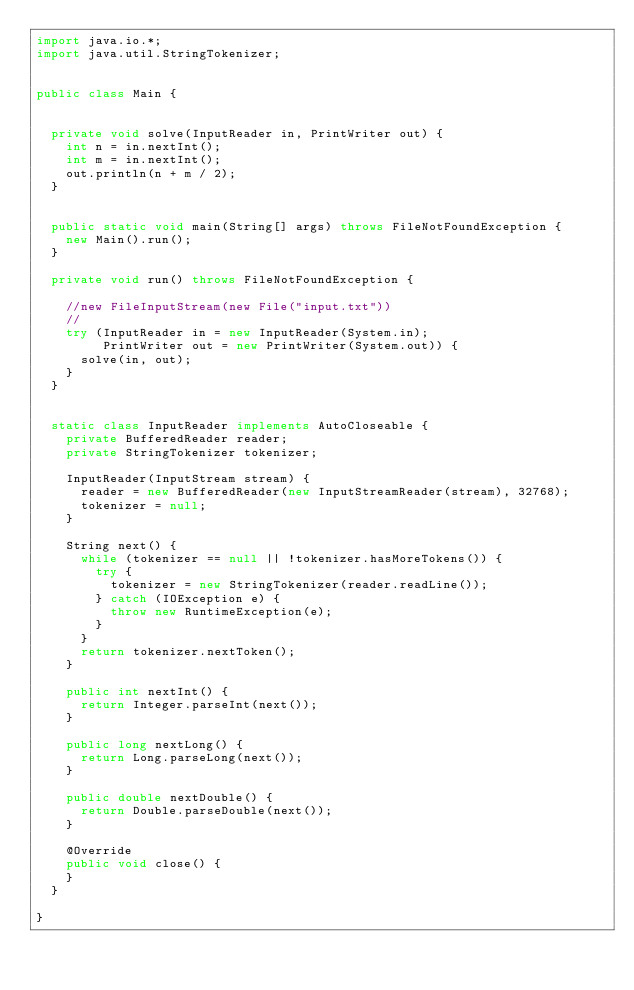<code> <loc_0><loc_0><loc_500><loc_500><_Java_>import java.io.*;
import java.util.StringTokenizer;


public class Main {


  private void solve(InputReader in, PrintWriter out) {
    int n = in.nextInt();
    int m = in.nextInt();
    out.println(n + m / 2);
  }


  public static void main(String[] args) throws FileNotFoundException {
    new Main().run();
  }

  private void run() throws FileNotFoundException {

    //new FileInputStream(new File("input.txt"))
    //
    try (InputReader in = new InputReader(System.in);
         PrintWriter out = new PrintWriter(System.out)) {
      solve(in, out);
    }
  }


  static class InputReader implements AutoCloseable {
    private BufferedReader reader;
    private StringTokenizer tokenizer;

    InputReader(InputStream stream) {
      reader = new BufferedReader(new InputStreamReader(stream), 32768);
      tokenizer = null;
    }

    String next() {
      while (tokenizer == null || !tokenizer.hasMoreTokens()) {
        try {
          tokenizer = new StringTokenizer(reader.readLine());
        } catch (IOException e) {
          throw new RuntimeException(e);
        }
      }
      return tokenizer.nextToken();
    }

    public int nextInt() {
      return Integer.parseInt(next());
    }

    public long nextLong() {
      return Long.parseLong(next());
    }

    public double nextDouble() {
      return Double.parseDouble(next());
    }

    @Override
    public void close() {
    }
  }

}
</code> 